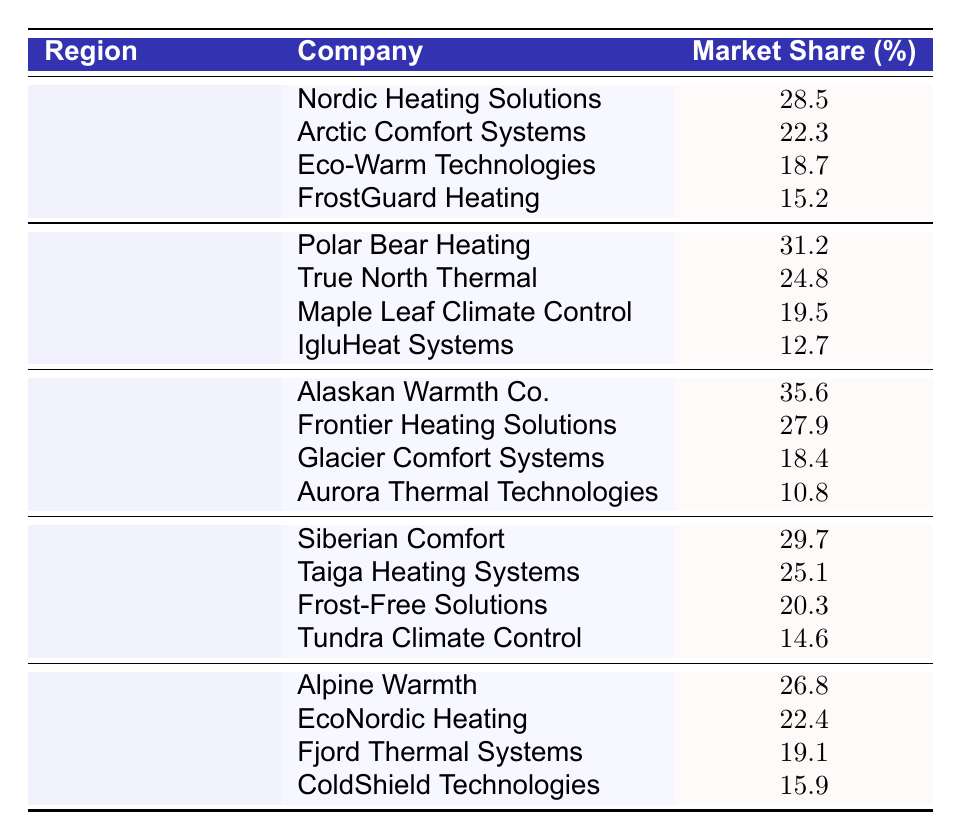What company has the highest market share in Alaska? From the table, looking at the "Alaska" section, "Alaskan Warmth Co." is listed first with a market share of 35.6%, which is the highest among the listed companies in that region.
Answer: Alaskan Warmth Co What is the market share of Eco-Warm Technologies in Scandinavia? In the Scandinavia section, the company "Eco-Warm Technologies" has a market share of 18.7%, which is directly stated in the table.
Answer: 18.7% What is the total market share percentage of companies in Canada? To find the total market share in Canada, we add the market shares of all companies listed under that region: 31.2 + 24.8 + 19.5 + 12.7 = 88.2%.
Answer: 88.2% Which region has the lowest average market share? To find the region with the lowest average, we calculate the averages: Scandinavia: (28.5 + 22.3 + 18.7 + 15.2) / 4 = 21.175; Canada: (31.2 + 24.8 + 19.5 + 12.7) / 4 = 22.6; Alaska: (35.6 + 27.9 + 18.4 + 10.8) / 4 = 23.175; Siberia: (29.7 + 25.1 + 20.3 + 14.6) / 4 = 22.175; Northern Europe: (26.8 + 22.4 + 19.1 + 15.9) / 4 = 21.05. The lowest average is from Northern Europe at approximately 21.05%.
Answer: Northern Europe Is it true that Maple Leaf Climate Control has a higher market share than IgluHeat Systems in Canada? In the Canadian section, "Maple Leaf Climate Control" has a market share of 19.5%, while "IgluHeat Systems" has a market share of 12.7%. Since 19.5% is greater than 12.7%, the statement is true.
Answer: True What percentage difference in market share exists between Polar Bear Heating and True North Thermal in Canada? The market share for Polar Bear Heating is 31.2% and for True North Thermal it is 24.8%. To find the difference, we subtract: 31.2 - 24.8 = 6.4%.
Answer: 6.4% What company has the second highest market share in Siberia? In the Siberia section, "Siberian Comfort" has the highest share at 29.7%, and "Taiga Heating Systems" comes next with 25.1%. Therefore, the second highest market share in Siberia is from Taiga Heating Systems.
Answer: Taiga Heating Systems Which region has the highest individual company market share and what is that percentage? Looking at the table, Alaska's "Alaskan Warmth Co." has the highest market share at 35.6%. This is the highest individual company share across all regions listed in the table.
Answer: 35.6% 